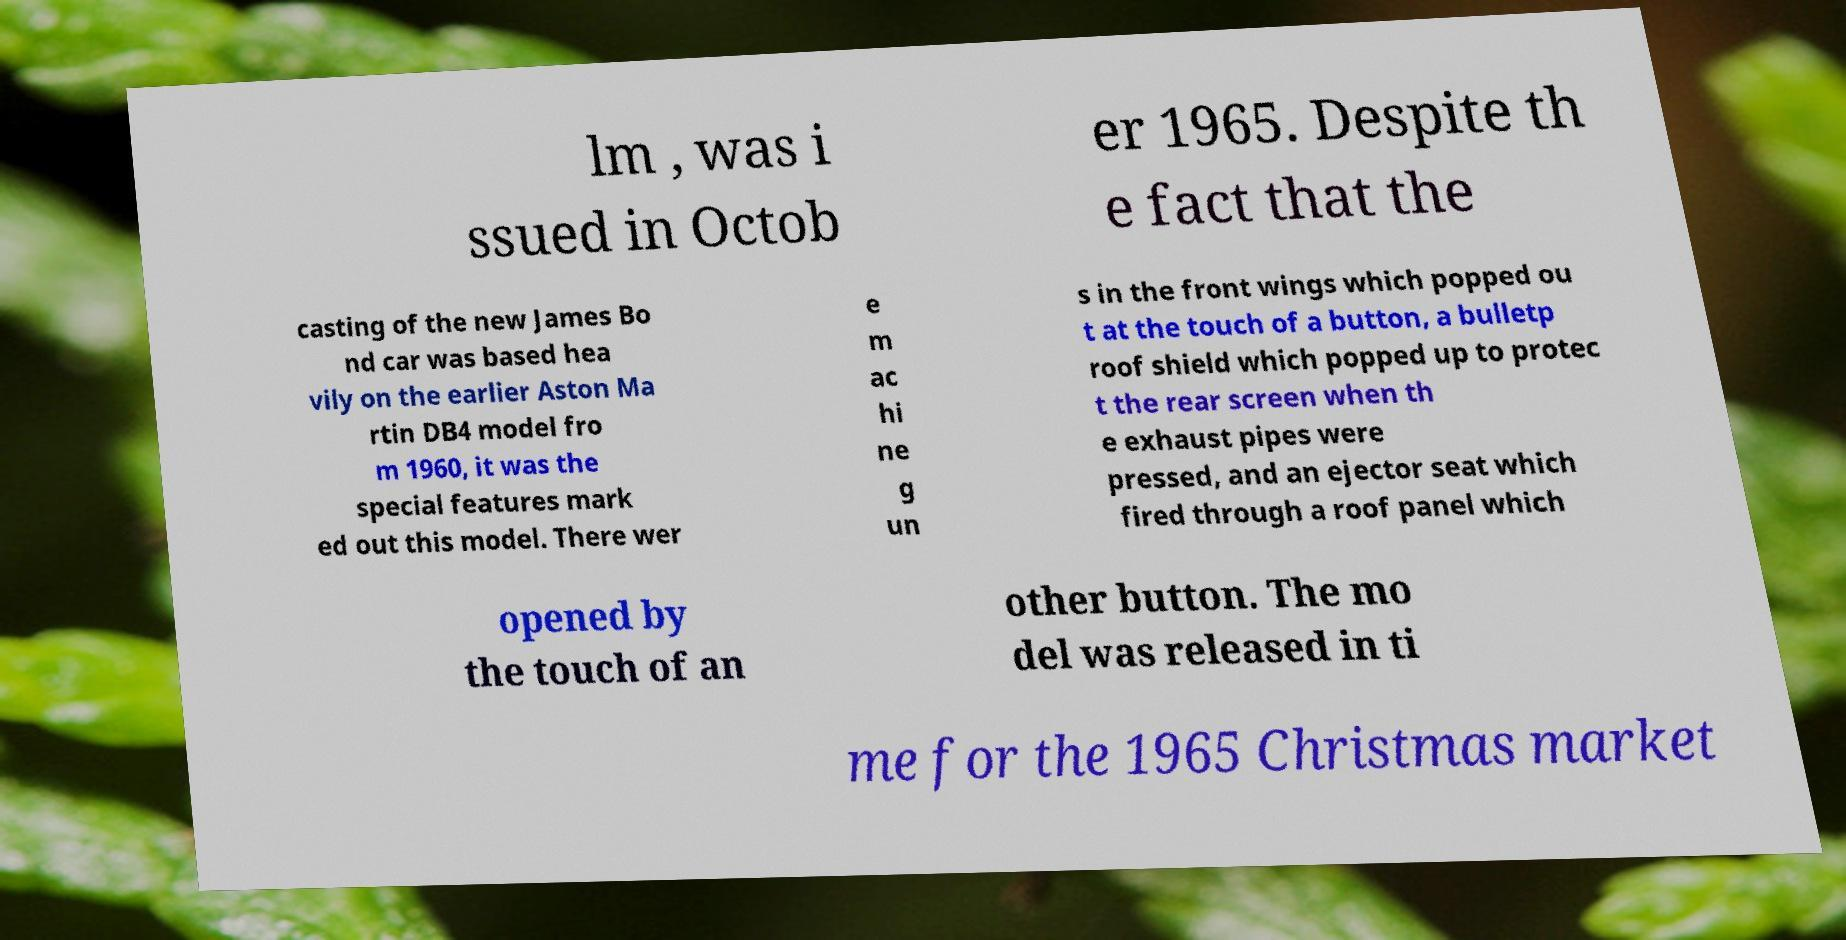Could you extract and type out the text from this image? lm , was i ssued in Octob er 1965. Despite th e fact that the casting of the new James Bo nd car was based hea vily on the earlier Aston Ma rtin DB4 model fro m 1960, it was the special features mark ed out this model. There wer e m ac hi ne g un s in the front wings which popped ou t at the touch of a button, a bulletp roof shield which popped up to protec t the rear screen when th e exhaust pipes were pressed, and an ejector seat which fired through a roof panel which opened by the touch of an other button. The mo del was released in ti me for the 1965 Christmas market 